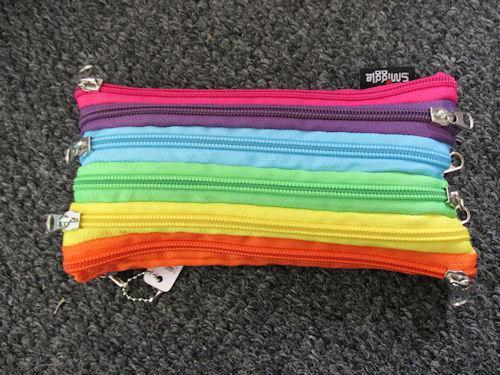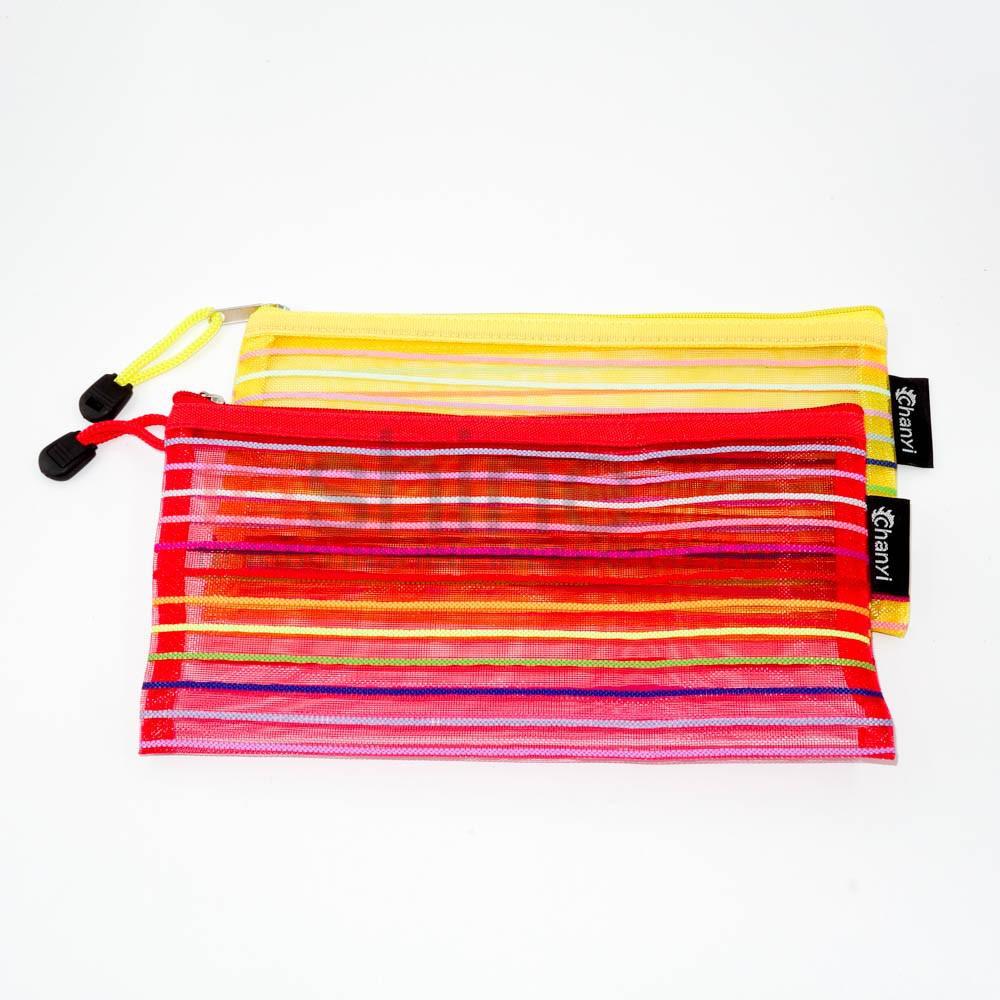The first image is the image on the left, the second image is the image on the right. For the images displayed, is the sentence "The pair of images contain nearly identical items, with the same colors." factually correct? Answer yes or no. No. 